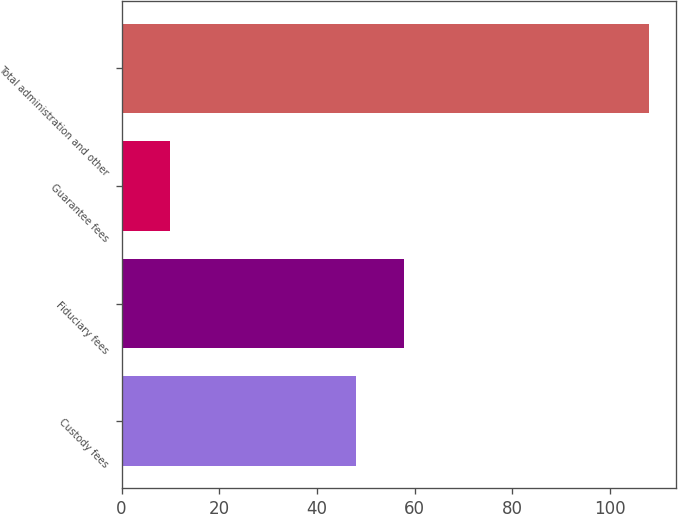Convert chart. <chart><loc_0><loc_0><loc_500><loc_500><bar_chart><fcel>Custody fees<fcel>Fiduciary fees<fcel>Guarantee fees<fcel>Total administration and other<nl><fcel>48<fcel>57.8<fcel>10<fcel>108<nl></chart> 